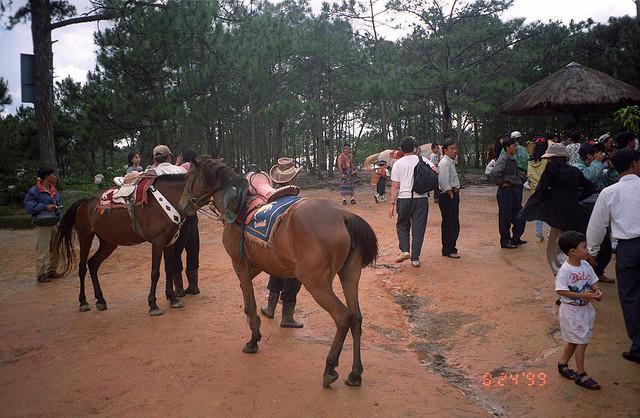How many horses are there?
Give a very brief answer. 2. How many people are there?
Give a very brief answer. 7. How many giraffe is in the picture?
Give a very brief answer. 0. 